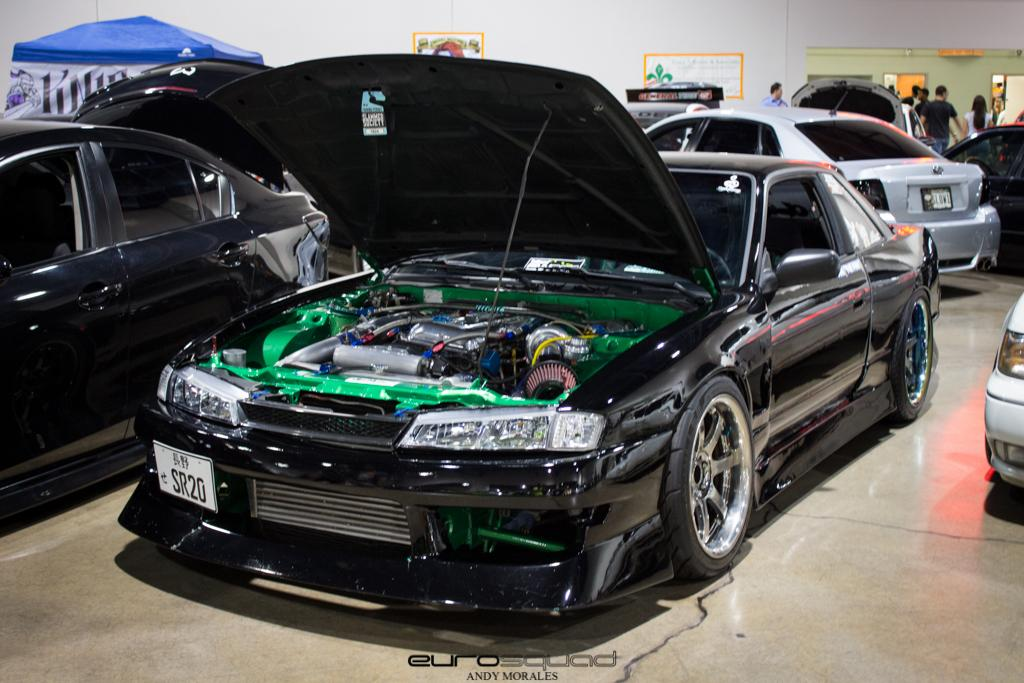What is the main subject of the image? The main subject of the image is many cars. What can be seen on the wall in the image? There are posters on the wall in the image. Where are the people located in the image? The people are at the right side of the image. What structure is present at the left side of the image? There is a tent at the left side of the image. How many frogs are present in the image? There are no frogs present in the image. What is the amount of respect shown by the cars in the image? Cars do not have the ability to show respect, as they are inanimate objects. 